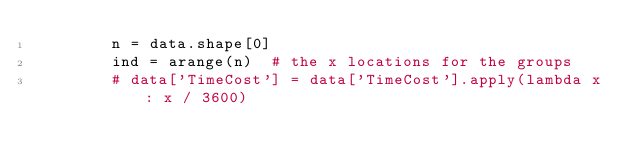Convert code to text. <code><loc_0><loc_0><loc_500><loc_500><_Python_>        n = data.shape[0]
        ind = arange(n)  # the x locations for the groups
        # data['TimeCost'] = data['TimeCost'].apply(lambda x: x / 3600)</code> 